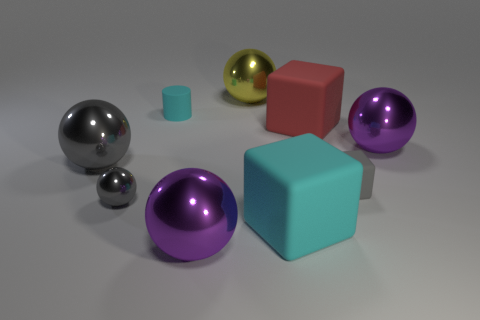Which object stands out the most to you, and why? The large red block stands out the most, primarily because of its bold color that contrasts sharply with the more subdued tones of the other objects. Its solid and unreflective surface also sets it apart from the shiny, metallic object and the reflective purple spheres. 